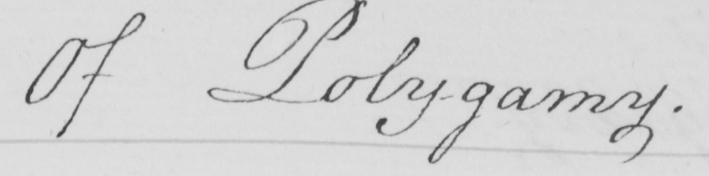Can you read and transcribe this handwriting? Of Polygamy . 